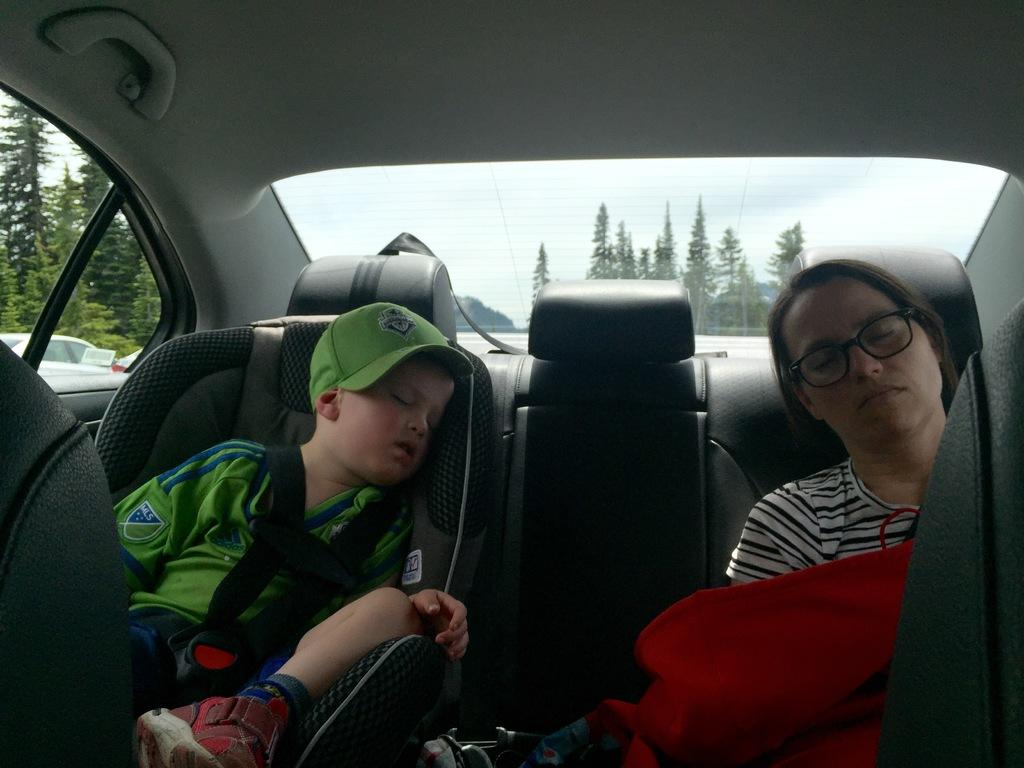Where was the image taken? The image was taken inside a car. How many people are in the car? There are two people in the car. What are the two people doing? One person is sitting, and the other person is sleeping. What can be seen in the background of the image? Trees and the sky are visible in the background. What type of cloud can be seen in the image? There is no cloud visible in the image; only trees and the sky are present in the background. 